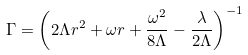Convert formula to latex. <formula><loc_0><loc_0><loc_500><loc_500>\Gamma = \left ( 2 \Lambda r ^ { 2 } + \omega r + \frac { \omega ^ { 2 } } { 8 \Lambda } - \frac { \lambda } { 2 \Lambda } \right ) ^ { - 1 }</formula> 